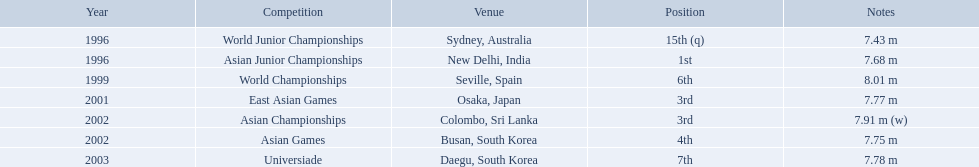What are all of the competitions? World Junior Championships, Asian Junior Championships, World Championships, East Asian Games, Asian Championships, Asian Games, Universiade. What was his positions in these competitions? 15th (q), 1st, 6th, 3rd, 3rd, 4th, 7th. And during which competition did he reach 1st place? Asian Junior Championships. What rankings has this competitor placed through the competitions? 15th (q), 1st, 6th, 3rd, 3rd, 4th, 7th. In which competition did the competitor place 1st? Asian Junior Championships. What are the competitions that huang le participated in? World Junior Championships, Asian Junior Championships, World Championships, East Asian Games, Asian Championships, Asian Games, Universiade. Which competitions did he participate in 2002 Asian Championships, Asian Games. What are the lengths of his jumps that year? 7.91 m (w), 7.75 m. What is the longest length of a jump? 7.91 m (w). In which contests did huang le participate? World Junior Championships, Asian Junior Championships, World Championships, East Asian Games, Asian Championships, Asian Games, Universiade. What lengths did he reach in these contests? 7.43 m, 7.68 m, 8.01 m, 7.77 m, 7.91 m (w), 7.75 m, 7.78 m. Which of these lengths was the greatest? 7.91 m (w). What jumps did huang le execute in 2002? 7.91 m (w), 7.75 m. Which jump had the maximum length? 7.91 m (w). Which tournament did huang le reach 3rd place? East Asian Games. Which tournament did he reach 4th place? Asian Games. When did he achieve the top position? Asian Junior Championships. In which challenges did huang le engage? World Junior Championships, Asian Junior Championships, World Championships, East Asian Games, Asian Championships, Asian Games, Universiade. What distances did he attain in these challenges? 7.43 m, 7.68 m, 8.01 m, 7.77 m, 7.91 m (w), 7.75 m, 7.78 m. Which of these distances was the furthest? 7.91 m (w). In which contest did huang le secure the 3rd position? East Asian Games. In which contest did he obtain the 4th position? Asian Games. When did he accomplish the 1st position? Asian Junior Championships. Which competition saw huang le finishing in 3rd place? East Asian Games. In which competition did he end up in 4th place? Asian Games. When did he manage to clinch the 1st place? Asian Junior Championships. What is the list of competitions he participated in? World Junior Championships, Asian Junior Championships, World Championships, East Asian Games, Asian Championships, Asian Games, Universiade. In which positions did he rank in those events? 15th (q), 1st, 6th, 3rd, 3rd, 4th, 7th. In which competition did he achieve 1st place? Asian Junior Championships. In which competitions did he take part? World Junior Championships, Asian Junior Championships, World Championships, East Asian Games, Asian Championships, Asian Games, Universiade. What were his rankings in each of these contests? 15th (q), 1st, 6th, 3rd, 3rd, 4th, 7th. During which event did he secure the top position? Asian Junior Championships. In which competitions has this competitor achieved various rankings? 15th (q), 1st, 6th, 3rd, 3rd, 4th, 7th. In which contest did they secure the 1st place? Asian Junior Championships. 